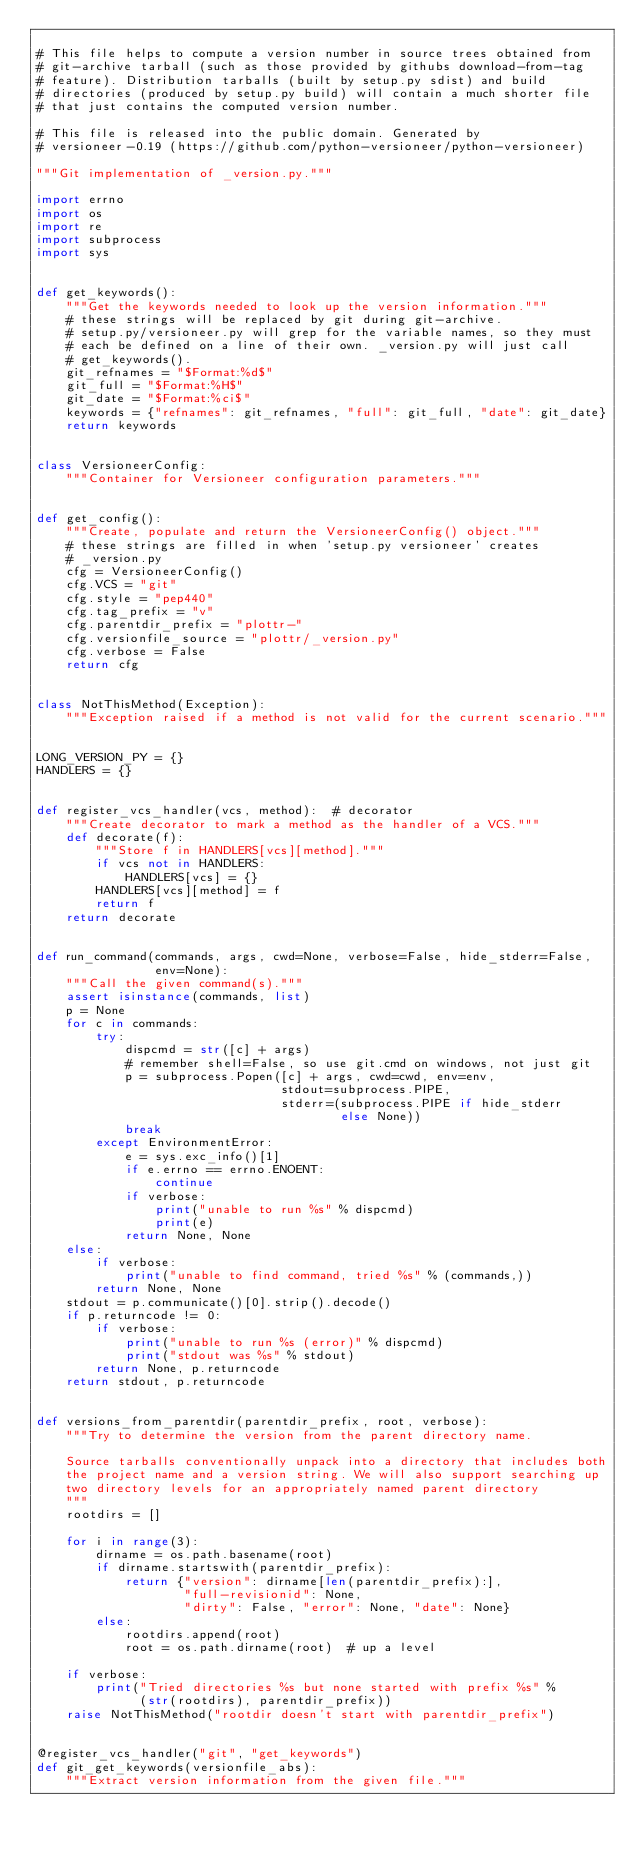<code> <loc_0><loc_0><loc_500><loc_500><_Python_>
# This file helps to compute a version number in source trees obtained from
# git-archive tarball (such as those provided by githubs download-from-tag
# feature). Distribution tarballs (built by setup.py sdist) and build
# directories (produced by setup.py build) will contain a much shorter file
# that just contains the computed version number.

# This file is released into the public domain. Generated by
# versioneer-0.19 (https://github.com/python-versioneer/python-versioneer)

"""Git implementation of _version.py."""

import errno
import os
import re
import subprocess
import sys


def get_keywords():
    """Get the keywords needed to look up the version information."""
    # these strings will be replaced by git during git-archive.
    # setup.py/versioneer.py will grep for the variable names, so they must
    # each be defined on a line of their own. _version.py will just call
    # get_keywords().
    git_refnames = "$Format:%d$"
    git_full = "$Format:%H$"
    git_date = "$Format:%ci$"
    keywords = {"refnames": git_refnames, "full": git_full, "date": git_date}
    return keywords


class VersioneerConfig:
    """Container for Versioneer configuration parameters."""


def get_config():
    """Create, populate and return the VersioneerConfig() object."""
    # these strings are filled in when 'setup.py versioneer' creates
    # _version.py
    cfg = VersioneerConfig()
    cfg.VCS = "git"
    cfg.style = "pep440"
    cfg.tag_prefix = "v"
    cfg.parentdir_prefix = "plottr-"
    cfg.versionfile_source = "plottr/_version.py"
    cfg.verbose = False
    return cfg


class NotThisMethod(Exception):
    """Exception raised if a method is not valid for the current scenario."""


LONG_VERSION_PY = {}
HANDLERS = {}


def register_vcs_handler(vcs, method):  # decorator
    """Create decorator to mark a method as the handler of a VCS."""
    def decorate(f):
        """Store f in HANDLERS[vcs][method]."""
        if vcs not in HANDLERS:
            HANDLERS[vcs] = {}
        HANDLERS[vcs][method] = f
        return f
    return decorate


def run_command(commands, args, cwd=None, verbose=False, hide_stderr=False,
                env=None):
    """Call the given command(s)."""
    assert isinstance(commands, list)
    p = None
    for c in commands:
        try:
            dispcmd = str([c] + args)
            # remember shell=False, so use git.cmd on windows, not just git
            p = subprocess.Popen([c] + args, cwd=cwd, env=env,
                                 stdout=subprocess.PIPE,
                                 stderr=(subprocess.PIPE if hide_stderr
                                         else None))
            break
        except EnvironmentError:
            e = sys.exc_info()[1]
            if e.errno == errno.ENOENT:
                continue
            if verbose:
                print("unable to run %s" % dispcmd)
                print(e)
            return None, None
    else:
        if verbose:
            print("unable to find command, tried %s" % (commands,))
        return None, None
    stdout = p.communicate()[0].strip().decode()
    if p.returncode != 0:
        if verbose:
            print("unable to run %s (error)" % dispcmd)
            print("stdout was %s" % stdout)
        return None, p.returncode
    return stdout, p.returncode


def versions_from_parentdir(parentdir_prefix, root, verbose):
    """Try to determine the version from the parent directory name.

    Source tarballs conventionally unpack into a directory that includes both
    the project name and a version string. We will also support searching up
    two directory levels for an appropriately named parent directory
    """
    rootdirs = []

    for i in range(3):
        dirname = os.path.basename(root)
        if dirname.startswith(parentdir_prefix):
            return {"version": dirname[len(parentdir_prefix):],
                    "full-revisionid": None,
                    "dirty": False, "error": None, "date": None}
        else:
            rootdirs.append(root)
            root = os.path.dirname(root)  # up a level

    if verbose:
        print("Tried directories %s but none started with prefix %s" %
              (str(rootdirs), parentdir_prefix))
    raise NotThisMethod("rootdir doesn't start with parentdir_prefix")


@register_vcs_handler("git", "get_keywords")
def git_get_keywords(versionfile_abs):
    """Extract version information from the given file."""</code> 